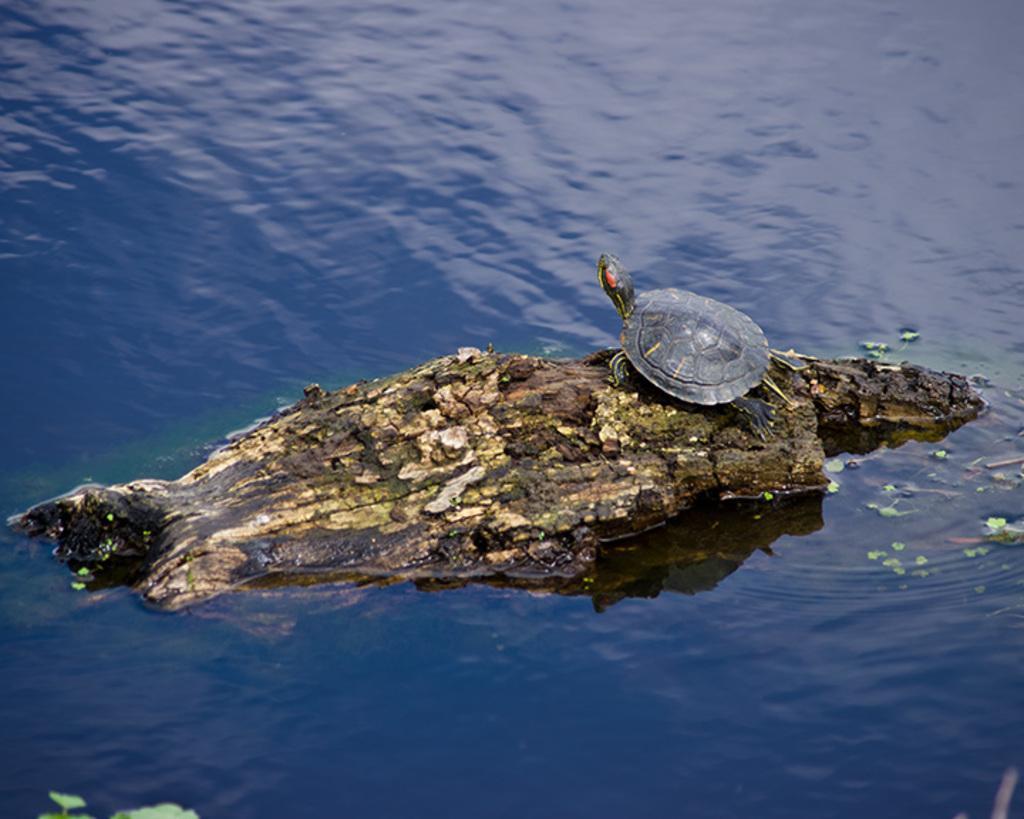How would you summarize this image in a sentence or two? In this image we can see a wood floating on the water and tortoise standing on the wood. 